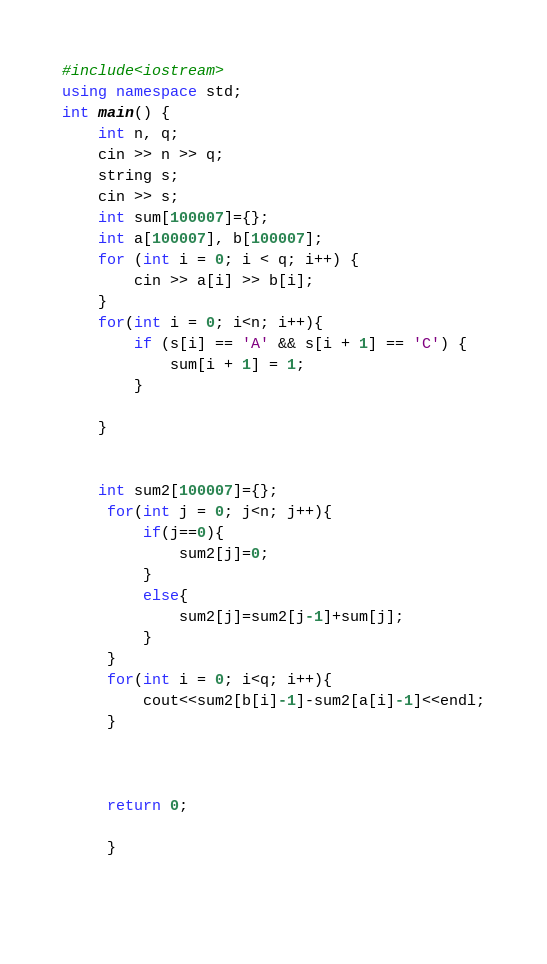<code> <loc_0><loc_0><loc_500><loc_500><_C++_>#include<iostream>
using namespace std;
int main() {
	int n, q;
	cin >> n >> q;
	string s;
	cin >> s;
	int sum[100007]={};
	int a[100007], b[100007];
	for (int i = 0; i < q; i++) {
		cin >> a[i] >> b[i];
	}
	for(int i = 0; i<n; i++){
	    if (s[i] == 'A' && s[i + 1] == 'C') {
			sum[i + 1] = 1;
		}
		
	}
	
	
	int sum2[100007]={};
	 for(int j = 0; j<n; j++){
	     if(j==0){
	         sum2[j]=0;
	     }
	     else{
	         sum2[j]=sum2[j-1]+sum[j];
	     }
	 }
	 for(int i = 0; i<q; i++){
	     cout<<sum2[b[i]-1]-sum2[a[i]-1]<<endl;
	 }
	    
	     
	 
	 return 0;
	 
	 }
	 
	</code> 